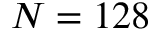Convert formula to latex. <formula><loc_0><loc_0><loc_500><loc_500>N = 1 2 8</formula> 